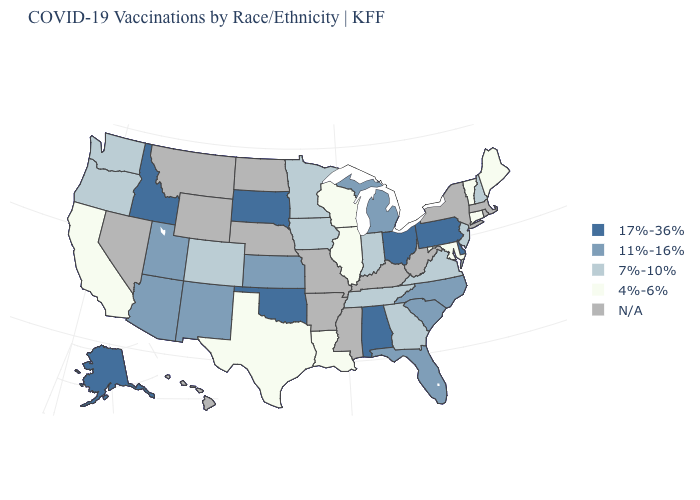Does Delaware have the highest value in the USA?
Concise answer only. Yes. How many symbols are there in the legend?
Concise answer only. 5. Name the states that have a value in the range 17%-36%?
Short answer required. Alabama, Alaska, Delaware, Idaho, Ohio, Oklahoma, Pennsylvania, South Dakota. Is the legend a continuous bar?
Short answer required. No. Name the states that have a value in the range N/A?
Write a very short answer. Arkansas, Hawaii, Kentucky, Massachusetts, Mississippi, Missouri, Montana, Nebraska, Nevada, New York, North Dakota, Rhode Island, West Virginia, Wyoming. Name the states that have a value in the range 17%-36%?
Be succinct. Alabama, Alaska, Delaware, Idaho, Ohio, Oklahoma, Pennsylvania, South Dakota. How many symbols are there in the legend?
Write a very short answer. 5. Name the states that have a value in the range 11%-16%?
Give a very brief answer. Arizona, Florida, Kansas, Michigan, New Mexico, North Carolina, South Carolina, Utah. Among the states that border Kansas , does Colorado have the highest value?
Give a very brief answer. No. Among the states that border Pennsylvania , which have the highest value?
Quick response, please. Delaware, Ohio. What is the value of Hawaii?
Be succinct. N/A. Among the states that border Iowa , which have the lowest value?
Answer briefly. Illinois, Wisconsin. Name the states that have a value in the range 4%-6%?
Concise answer only. California, Connecticut, Illinois, Louisiana, Maine, Maryland, Texas, Vermont, Wisconsin. Name the states that have a value in the range 11%-16%?
Concise answer only. Arizona, Florida, Kansas, Michigan, New Mexico, North Carolina, South Carolina, Utah. 